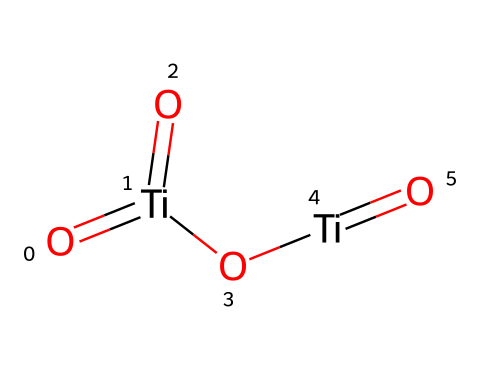What is the molecular formula of the chemical represented? The SMILES representation shows two titanium (Ti) atoms and four oxygen (O) atoms, resulting in the molecular formula Ti2O4.
Answer: Ti2O4 How many titanium atoms are present in this compound? By analyzing the SMILES structure, I count 2 titanium (Ti) atoms.
Answer: 2 What type of nanoparticles is represented by this chemical structure? This structure corresponds to titanium dioxide (TiO2) nanoparticles, which are commonly used in sunscreens for UV protection.
Answer: titanium dioxide What is the oxidation state of titanium in this compound? Each titanium atom is bonded to four oxygen atoms, with the typical oxidation state of titanium in titanium dioxide being +4.
Answer: +4 How many total bonds are present in this structure? The structure shows two Ti=O double bonds and two Ti-O single bonds, resulting in a total of 4 bonds.
Answer: 4 What role do titanium dioxide nanoparticles play in sunscreens? Titanium dioxide nanoparticles primarily act as a physical UVA/UVB blocker on the skin, reflecting and scattering UV radiation.
Answer: UV blocker What property of titanium dioxide nanoparticles makes them suitable for use in cosmetics? The nanoparticles have a high refractive index and excellent photostability, allowing for effective protection without leaving a visible residue.
Answer: refractive index 